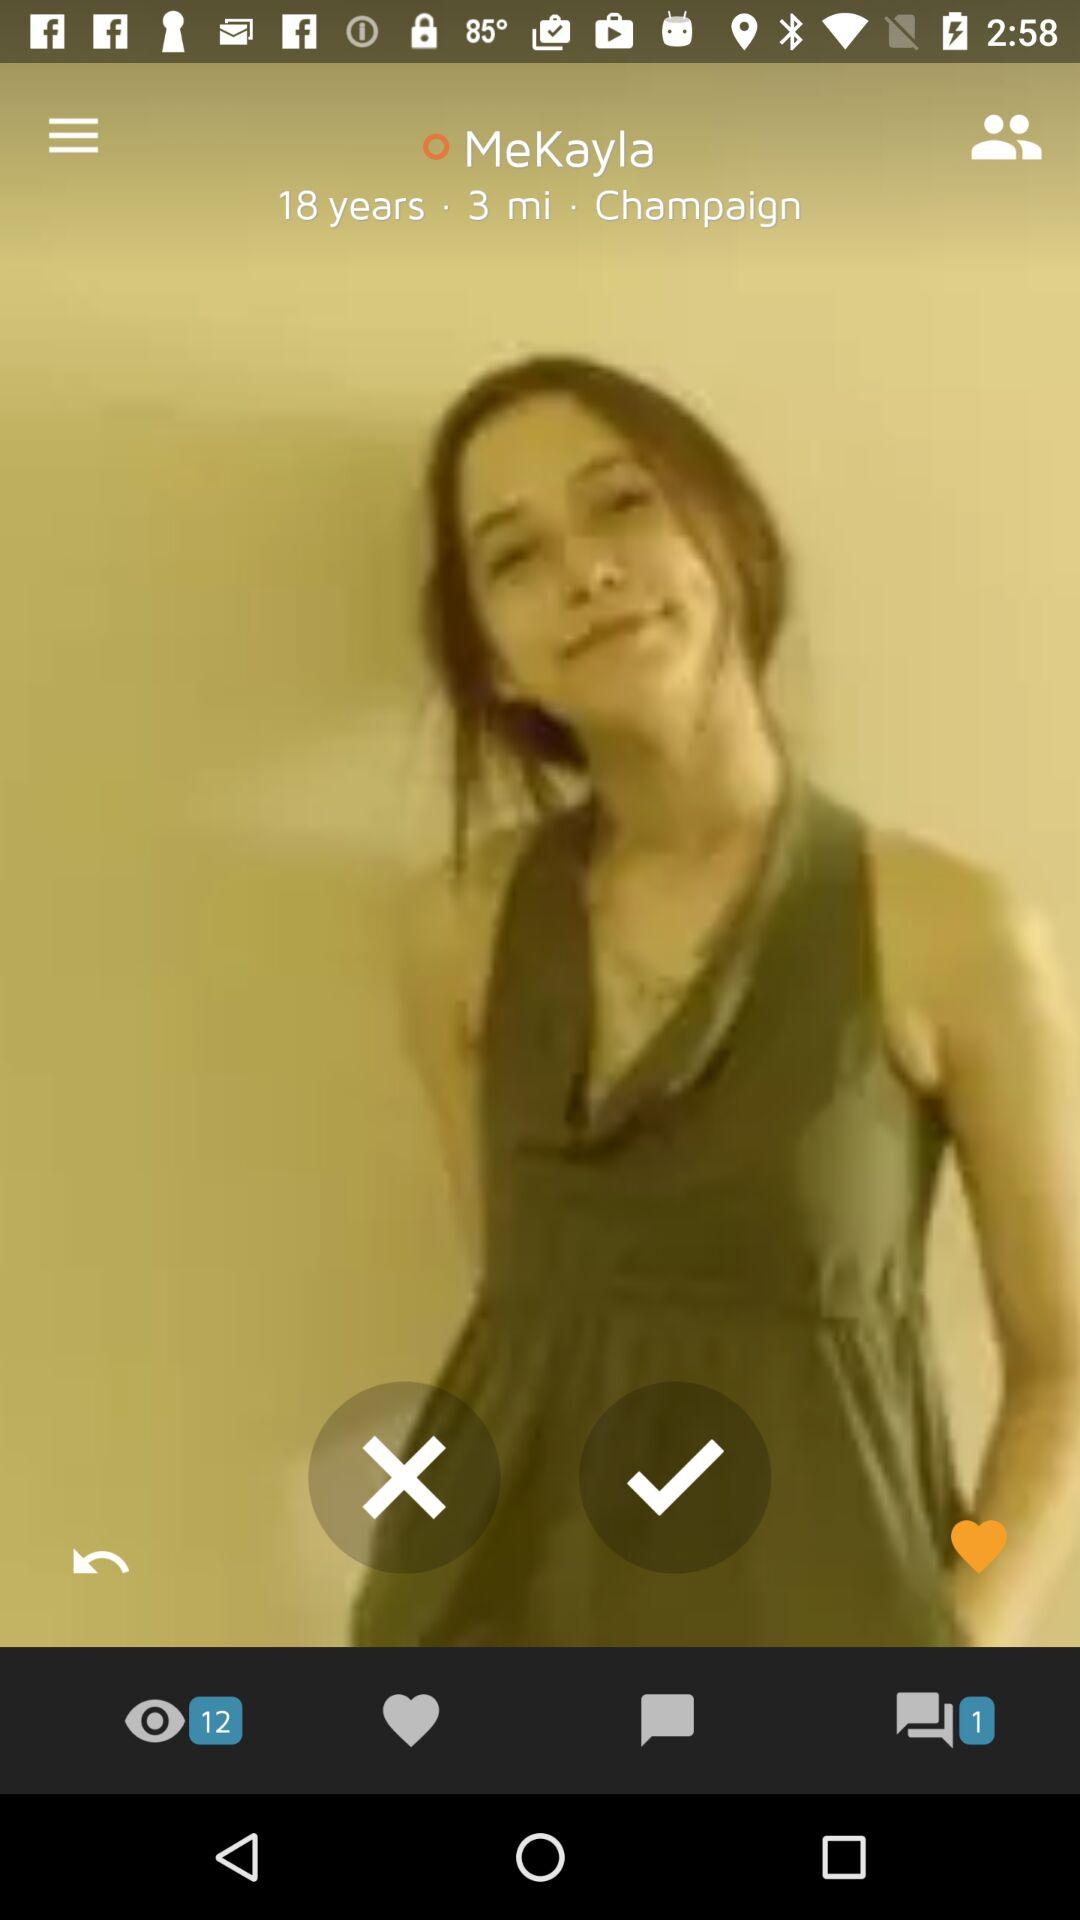What is the distance? The distance is 3 miles. 